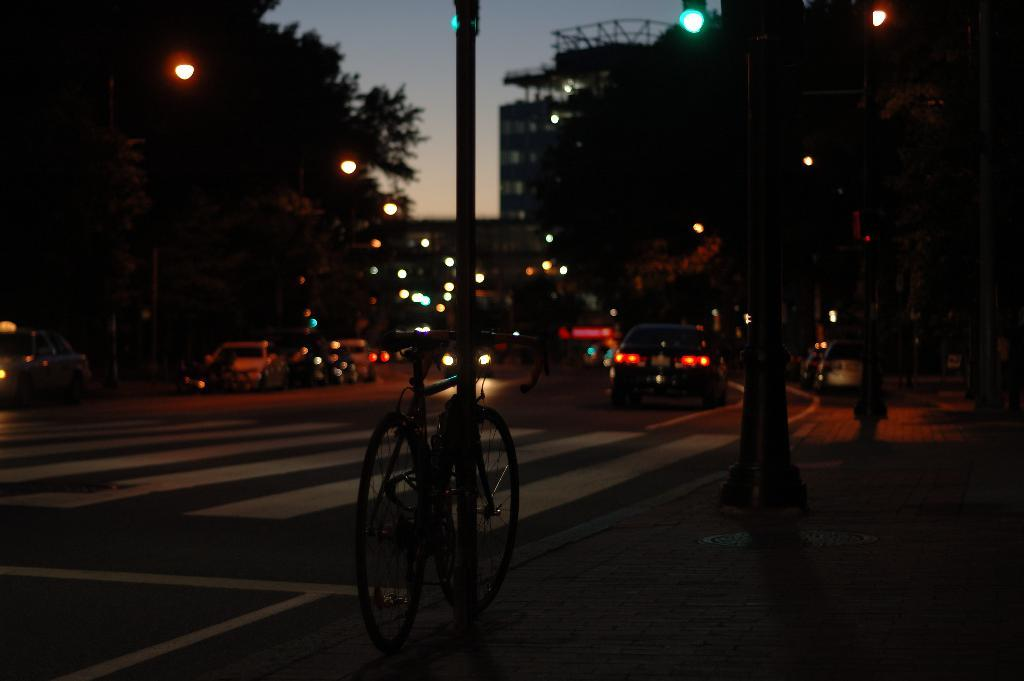What is located in the center of the image? There is a pole and a cycle in the center of the image. What can be seen on the road in the image? There are vehicles on the road. What is visible in the background of the image? The sky, trees, buildings, poles, and lights are visible in the background of the image. How many men are whistling at the table in the image? There are no men or tables present in the image. 